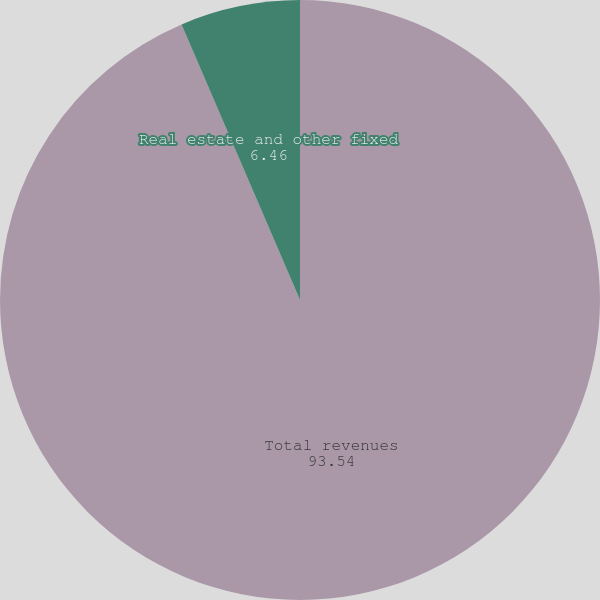Convert chart to OTSL. <chart><loc_0><loc_0><loc_500><loc_500><pie_chart><fcel>Total revenues<fcel>Real estate and other fixed<nl><fcel>93.54%<fcel>6.46%<nl></chart> 